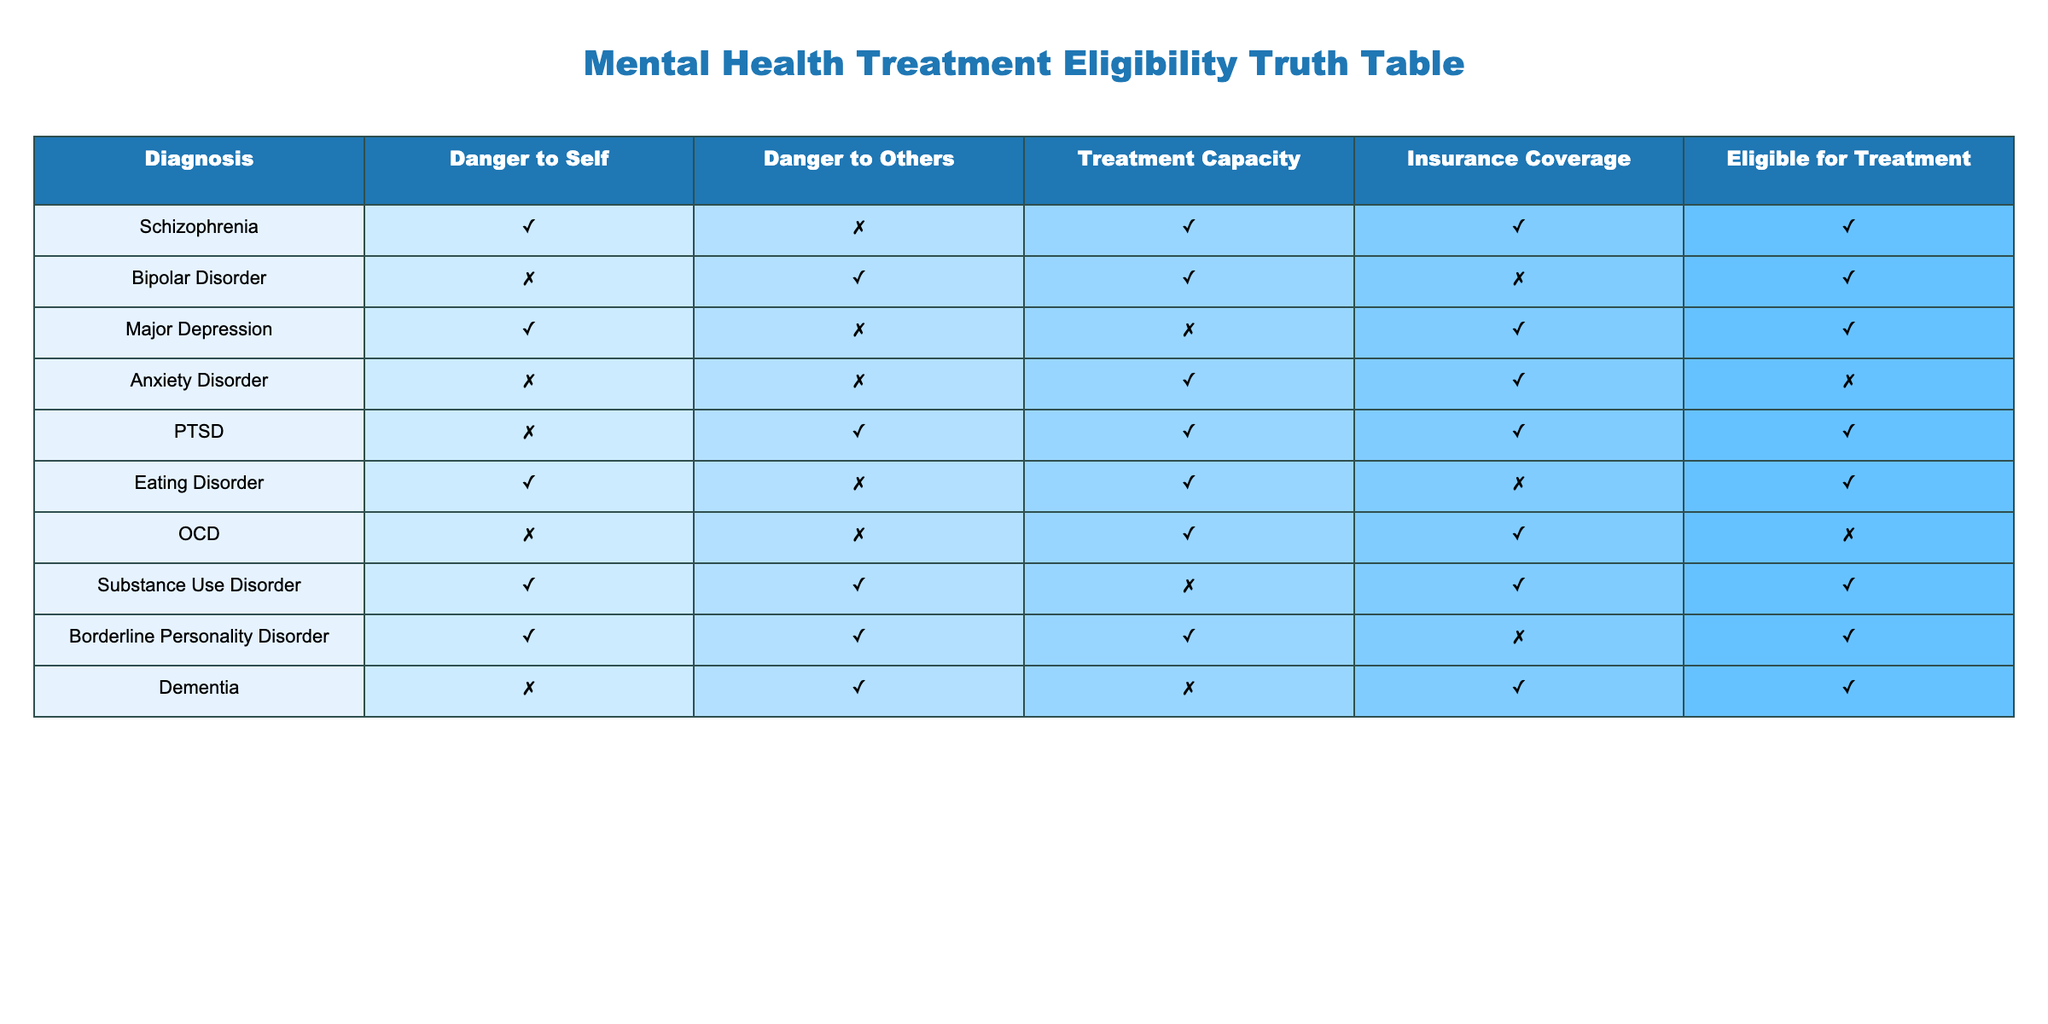What is the treatment capacity for Anxiety Disorder? The table shows that the treatment capacity for Anxiety Disorder is marked as FALSE, meaning it does not have the capacity for treatment.
Answer: FALSE Which diagnoses have both Danger to Self and Insurance Coverage as TRUE? By examining the table, I find that the diagnoses of Schizophrenia and Substance Use Disorder have both Danger to Self and Insurance Coverage as TRUE.
Answer: Schizophrenia, Substance Use Disorder How many diagnoses are eligible for treatment? To find this, I count the number of rows in the Eligible for Treatment column that are marked as TRUE. There are 6 diagnoses marked as eligible.
Answer: 6 Is PTSD eligible for treatment? According to the table, PTSD has a mark of TRUE in the Eligible for Treatment column, indicating that it is eligible for treatment.
Answer: YES Which diagnosis has Treatment Capacity as FALSE and is still eligible for treatment? From the table, Major Depression is the only diagnosis that has Treatment Capacity as FALSE (and it is marked as TRUE for Eligible for Treatment).
Answer: Major Depression How many diagnoses are both dangerous to others and eligible for treatment? The table lists Bipolar Disorder, PTSD, and Borderline Personality Disorder with Danger to Others as TRUE. All three are also eligible for treatment, resulting in a total of three diagnoses.
Answer: 3 Are there any diagnoses that are NOT dangerous to self and still eligible for treatment? Reviewing the table, Anxiety Disorder and OCD are both marked as NOT dangerous to self (FALSE) and also have FALSE in the Eligible for Treatment column, indicating that neither is eligible.
Answer: NO What is the total number of diagnoses that lack both Danger to Self and Danger to Others? Scanning the table, Anxiety Disorder and OCD are marked with both Danger to Self and Danger to Others as FALSE. Thus, there are a total of 2 diagnoses that fulfill this criterion.
Answer: 2 Which diagnosis is eligible for treatment even though it lacks Insurance Coverage? When checking the table, both Bipolar Disorder and Eating Disorder are eligible for treatment despite having FALSE in Insurance Coverage.
Answer: Bipolar Disorder, Eating Disorder 